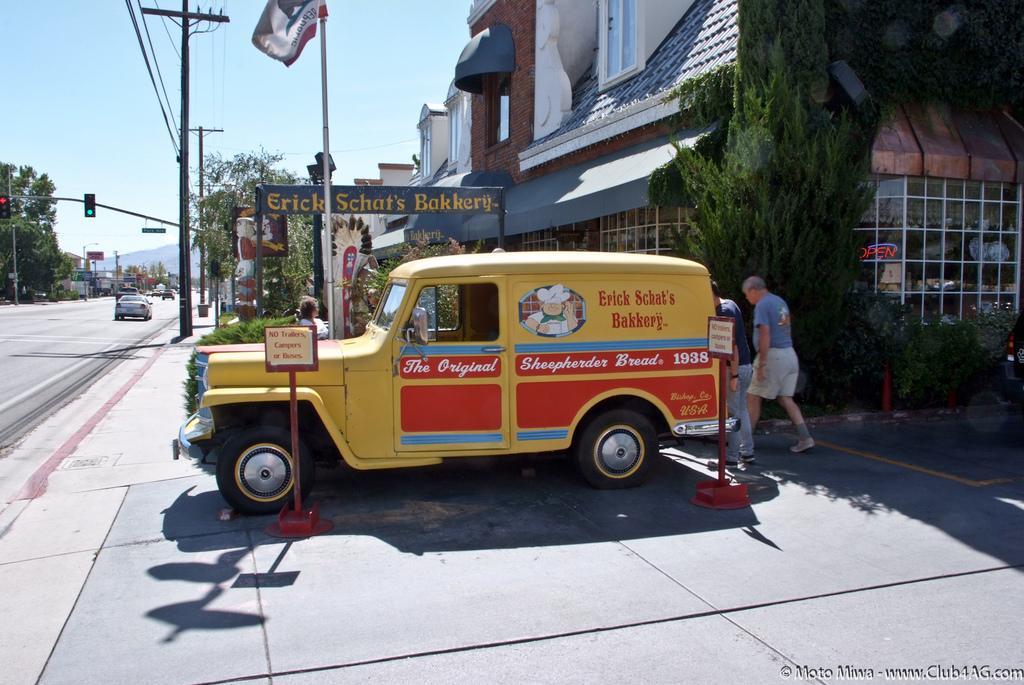Could you give a brief overview of what you see in this image? In this picture we can see vehicles on the road, some people, name boards, traffic signals, poles, flag, buildings, trees, wires, some objects and in the background we can see the sky. 